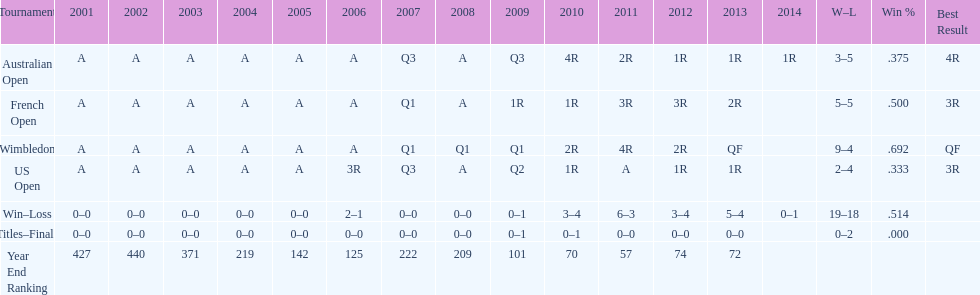What was this players ranking after 2005? 125. Write the full table. {'header': ['Tournament', '2001', '2002', '2003', '2004', '2005', '2006', '2007', '2008', '2009', '2010', '2011', '2012', '2013', '2014', 'W–L', 'Win %', 'Best Result'], 'rows': [['Australian Open', 'A', 'A', 'A', 'A', 'A', 'A', 'Q3', 'A', 'Q3', '4R', '2R', '1R', '1R', '1R', '3–5', '.375', '4R'], ['French Open', 'A', 'A', 'A', 'A', 'A', 'A', 'Q1', 'A', '1R', '1R', '3R', '3R', '2R', '', '5–5', '.500', '3R'], ['Wimbledon', 'A', 'A', 'A', 'A', 'A', 'A', 'Q1', 'Q1', 'Q1', '2R', '4R', '2R', 'QF', '', '9–4', '.692', 'QF'], ['US Open', 'A', 'A', 'A', 'A', 'A', '3R', 'Q3', 'A', 'Q2', '1R', 'A', '1R', '1R', '', '2–4', '.333', '3R'], ['Win–Loss', '0–0', '0–0', '0–0', '0–0', '0–0', '2–1', '0–0', '0–0', '0–1', '3–4', '6–3', '3–4', '5–4', '0–1', '19–18', '.514', ''], ['Titles–Finals', '0–0', '0–0', '0–0', '0–0', '0–0', '0–0', '0–0', '0–0', '0–1', '0–1', '0–0', '0–0', '0–0', '', '0–2', '.000', ''], ['Year End Ranking', '427', '440', '371', '219', '142', '125', '222', '209', '101', '70', '57', '74', '72', '', '', '', '']]} 